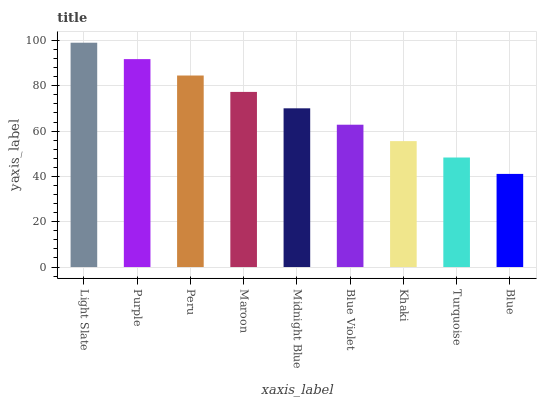Is Blue the minimum?
Answer yes or no. Yes. Is Light Slate the maximum?
Answer yes or no. Yes. Is Purple the minimum?
Answer yes or no. No. Is Purple the maximum?
Answer yes or no. No. Is Light Slate greater than Purple?
Answer yes or no. Yes. Is Purple less than Light Slate?
Answer yes or no. Yes. Is Purple greater than Light Slate?
Answer yes or no. No. Is Light Slate less than Purple?
Answer yes or no. No. Is Midnight Blue the high median?
Answer yes or no. Yes. Is Midnight Blue the low median?
Answer yes or no. Yes. Is Purple the high median?
Answer yes or no. No. Is Purple the low median?
Answer yes or no. No. 